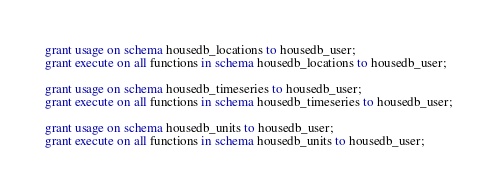<code> <loc_0><loc_0><loc_500><loc_500><_SQL_>
grant usage on schema housedb_locations to housedb_user;
grant execute on all functions in schema housedb_locations to housedb_user;

grant usage on schema housedb_timeseries to housedb_user;
grant execute on all functions in schema housedb_timeseries to housedb_user;

grant usage on schema housedb_units to housedb_user;
grant execute on all functions in schema housedb_units to housedb_user;</code> 